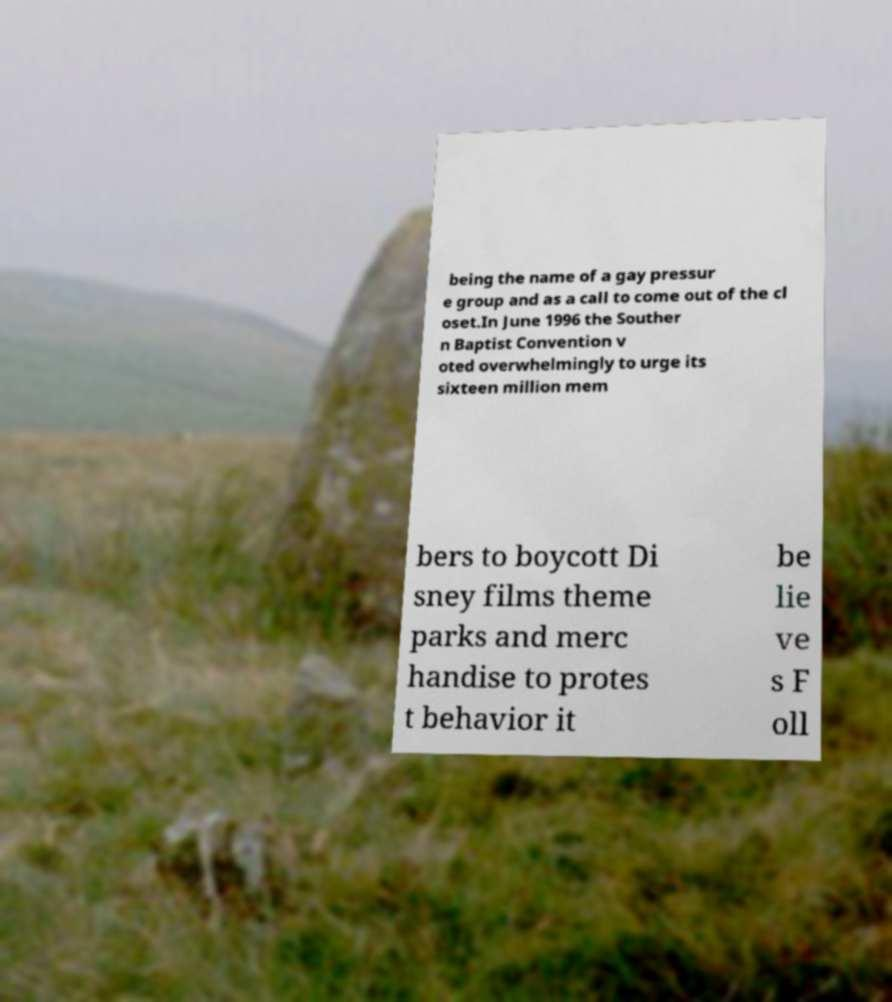There's text embedded in this image that I need extracted. Can you transcribe it verbatim? being the name of a gay pressur e group and as a call to come out of the cl oset.In June 1996 the Souther n Baptist Convention v oted overwhelmingly to urge its sixteen million mem bers to boycott Di sney films theme parks and merc handise to protes t behavior it be lie ve s F oll 